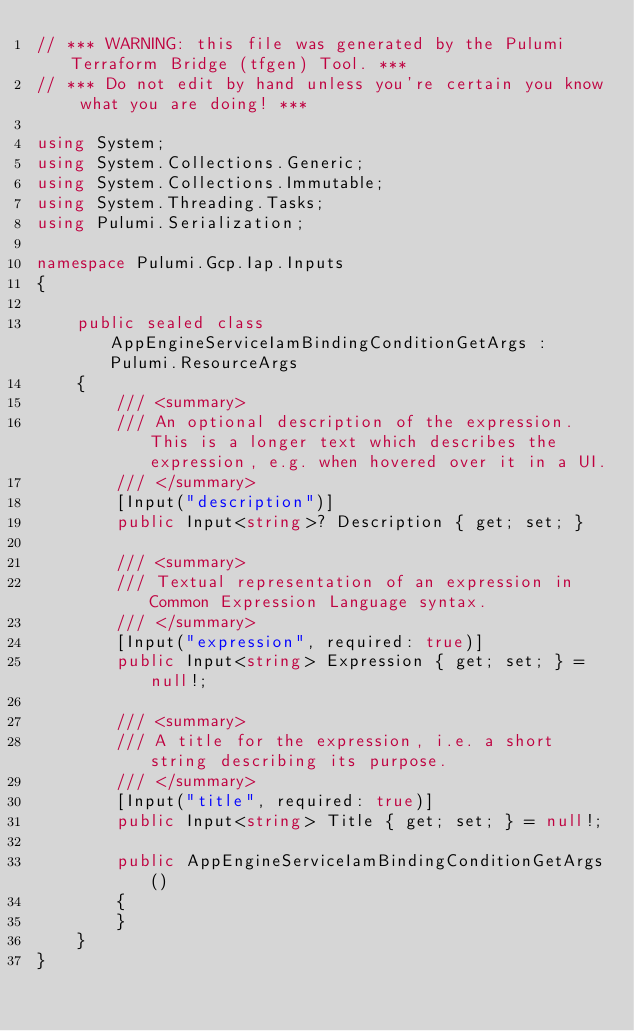<code> <loc_0><loc_0><loc_500><loc_500><_C#_>// *** WARNING: this file was generated by the Pulumi Terraform Bridge (tfgen) Tool. ***
// *** Do not edit by hand unless you're certain you know what you are doing! ***

using System;
using System.Collections.Generic;
using System.Collections.Immutable;
using System.Threading.Tasks;
using Pulumi.Serialization;

namespace Pulumi.Gcp.Iap.Inputs
{

    public sealed class AppEngineServiceIamBindingConditionGetArgs : Pulumi.ResourceArgs
    {
        /// <summary>
        /// An optional description of the expression. This is a longer text which describes the expression, e.g. when hovered over it in a UI.
        /// </summary>
        [Input("description")]
        public Input<string>? Description { get; set; }

        /// <summary>
        /// Textual representation of an expression in Common Expression Language syntax.
        /// </summary>
        [Input("expression", required: true)]
        public Input<string> Expression { get; set; } = null!;

        /// <summary>
        /// A title for the expression, i.e. a short string describing its purpose.
        /// </summary>
        [Input("title", required: true)]
        public Input<string> Title { get; set; } = null!;

        public AppEngineServiceIamBindingConditionGetArgs()
        {
        }
    }
}
</code> 